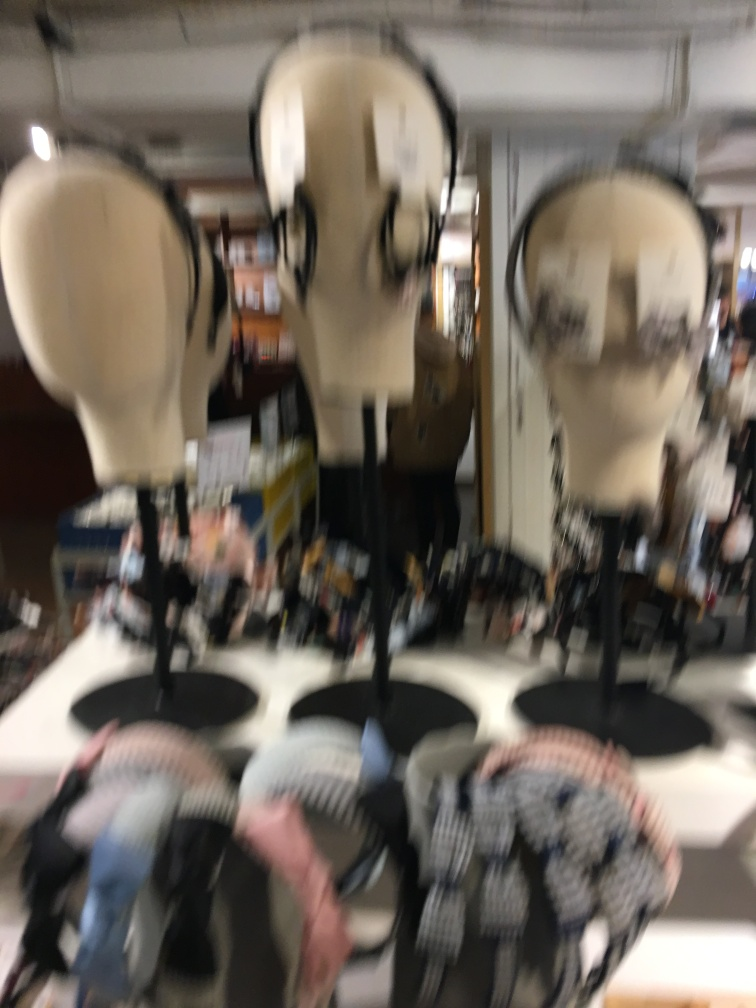What could be the context in which this image was taken, given the presence of mannequin heads? This image likely depicts a retail setting or a store display for hats, scarves, or other accessories. The arrangement indicates an environment focused on fashion or apparel merchandising. Due to the motion blur, it seems like a snapshot taken in passing, possibly by a shopper in movement. 